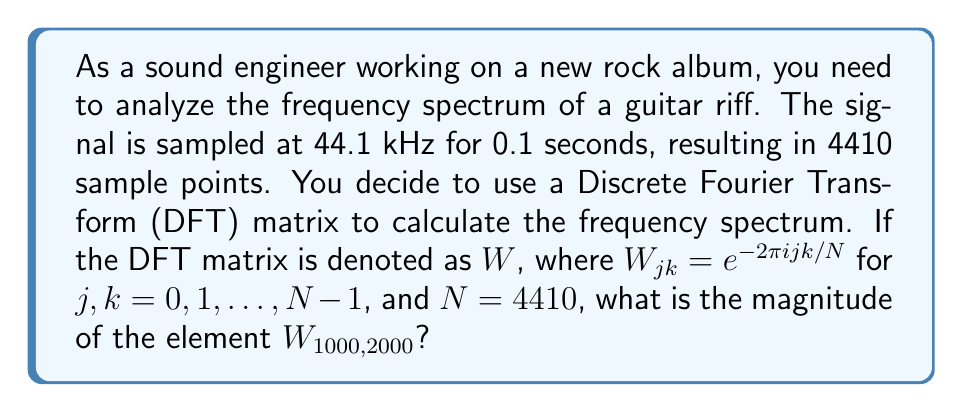Teach me how to tackle this problem. To solve this problem, we need to follow these steps:

1) Recall the formula for the elements of the DFT matrix:

   $W_{jk} = e^{-2\pi i jk/N}$

   Where $i$ is the imaginary unit, $j$ and $k$ are the row and column indices respectively, and $N$ is the total number of sample points.

2) In this case, we're asked about $W_{1000,2000}$, so $j=1000$, $k=2000$, and $N=4410$.

3) Let's substitute these values into the formula:

   $W_{1000,2000} = e^{-2\pi i (1000)(2000)/4410}$

4) Simplify the fraction inside the exponent:

   $W_{1000,2000} = e^{-2\pi i (2000000/4410)}$
   
   $= e^{-2\pi i (453.5147392290249)}$

5) We can simplify this further by recognizing that the exponential is periodic with period $2\pi i$. So we can subtract any integer multiple of $2\pi i$ from the exponent without changing the value:

   $W_{1000,2000} = e^{-2\pi i (453.5147392290249 - 453)}$
   
   $= e^{-2\pi i (0.5147392290249)}$

6) Now, to find the magnitude of this complex number, we use the fact that for any real $x$:

   $|e^{ix}| = 1$

This is because $e^{ix} = \cos x + i \sin x$, and $\sqrt{\cos^2 x + \sin^2 x} = 1$.

Therefore, regardless of the specific value inside the exponential, the magnitude will always be 1.
Answer: The magnitude of $W_{1000,2000}$ is 1. 